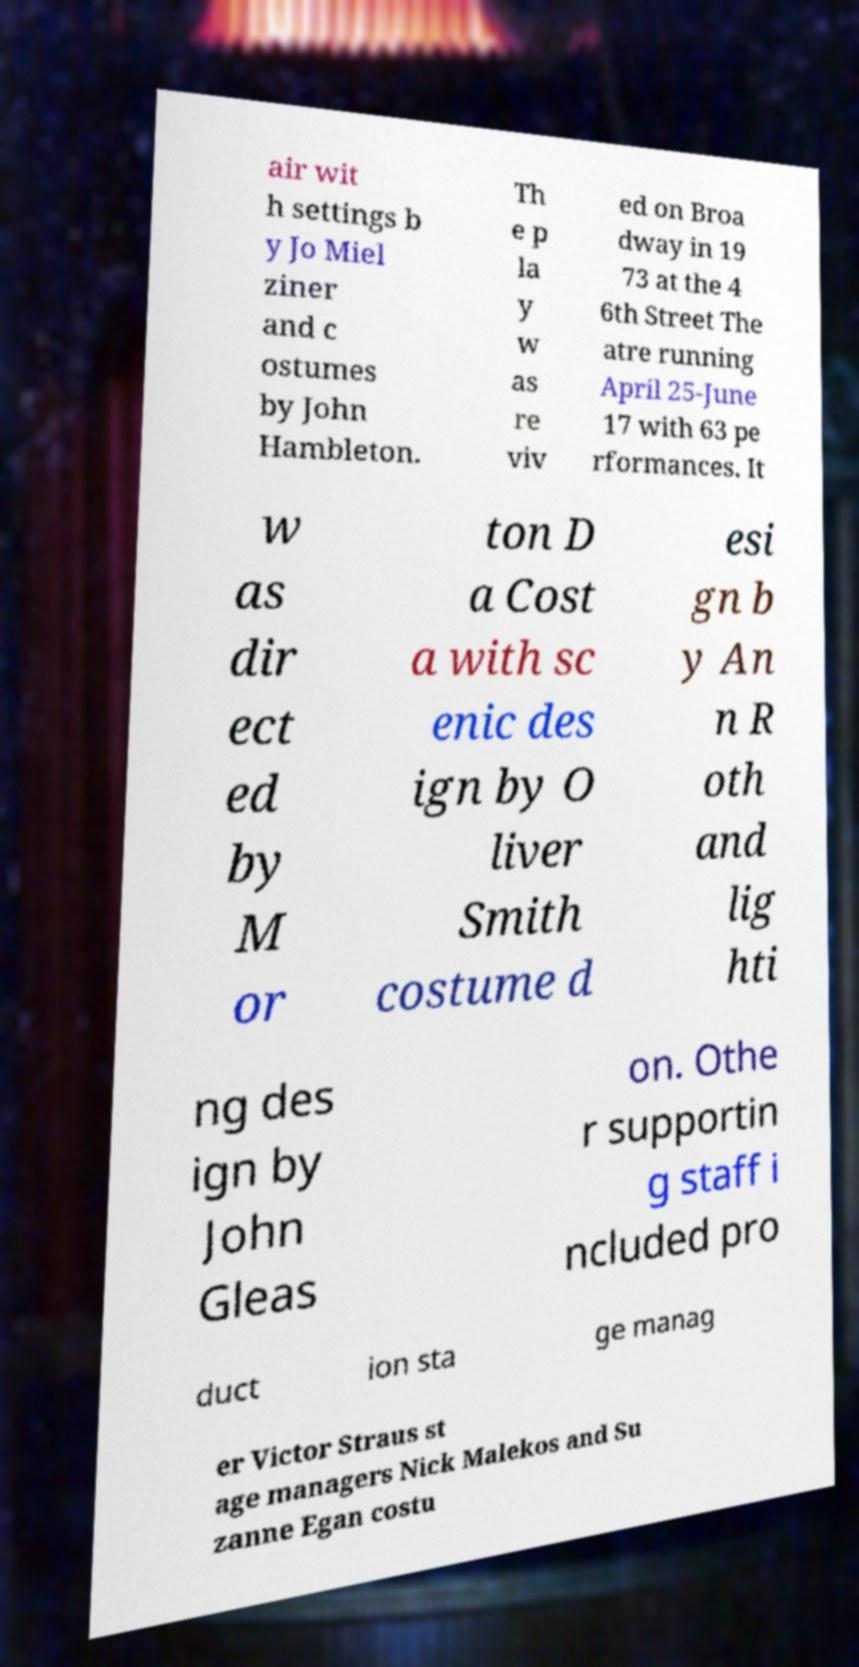There's text embedded in this image that I need extracted. Can you transcribe it verbatim? air wit h settings b y Jo Miel ziner and c ostumes by John Hambleton. Th e p la y w as re viv ed on Broa dway in 19 73 at the 4 6th Street The atre running April 25-June 17 with 63 pe rformances. It w as dir ect ed by M or ton D a Cost a with sc enic des ign by O liver Smith costume d esi gn b y An n R oth and lig hti ng des ign by John Gleas on. Othe r supportin g staff i ncluded pro duct ion sta ge manag er Victor Straus st age managers Nick Malekos and Su zanne Egan costu 